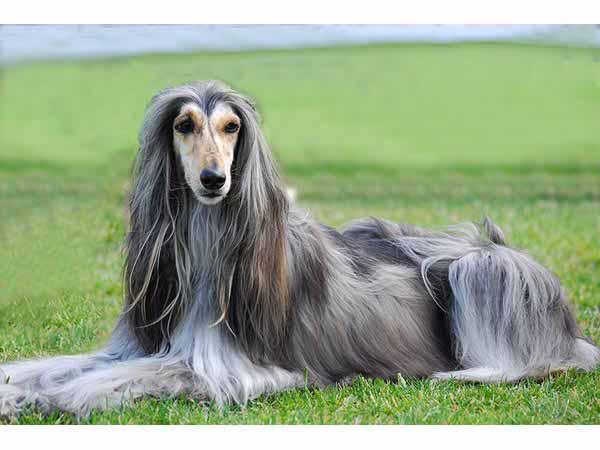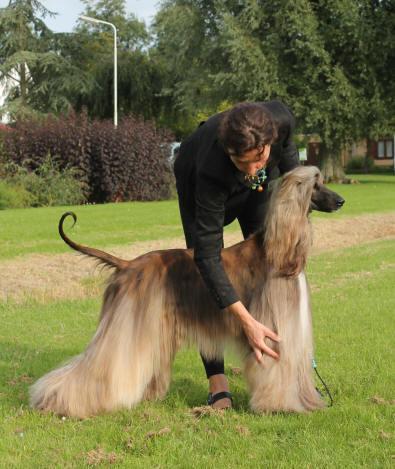The first image is the image on the left, the second image is the image on the right. For the images shown, is this caption "There is a person standing with the dog in the image on the right." true? Answer yes or no. Yes. The first image is the image on the left, the second image is the image on the right. Evaluate the accuracy of this statement regarding the images: "A person in blue jeans is standing behind a dark afghan hound facing leftward.". Is it true? Answer yes or no. No. 